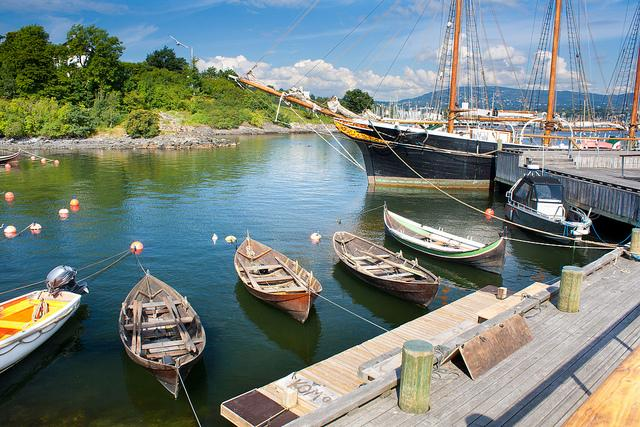What is the color of the sail boat? black 